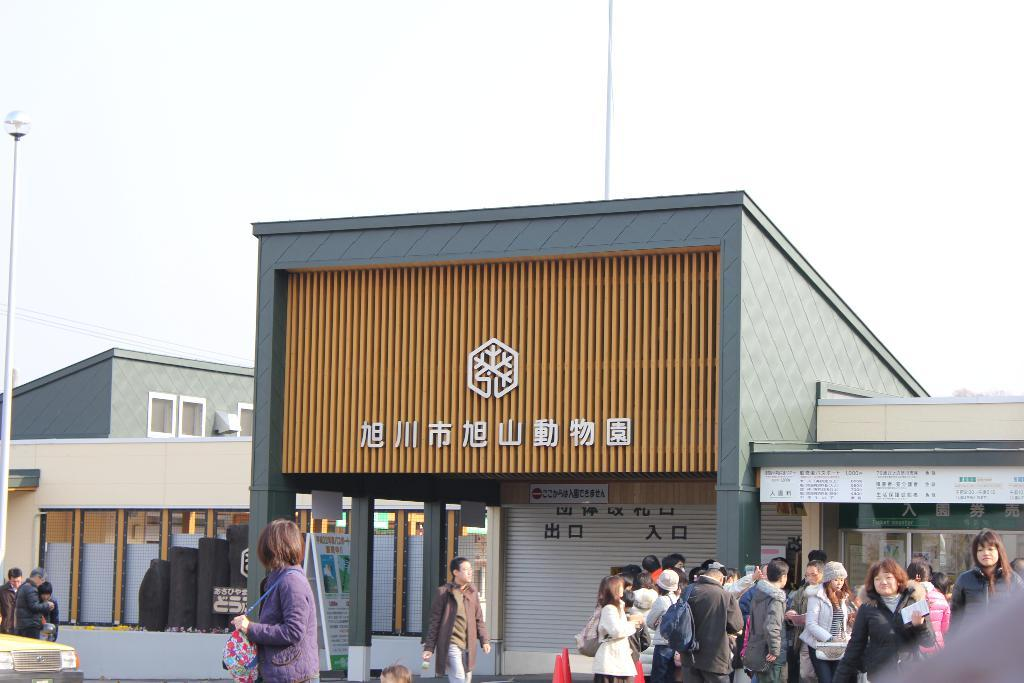What is the main subject in the foreground of the image? There is a building in the foreground of the image. What else can be seen in the foreground of the image? There is a crowd standing on the ground in the foreground of the image. What is visible in the background of the image? There are buildings, poles, and cables in the background of the image. What part of the natural environment is visible in the image? The sky is visible in the background of the image. How many pieces of cheese can be seen on the poles in the image? There is no cheese present on the poles in the image. What type of patch is covering the crowd in the image? There is no patch covering the crowd in the image. 